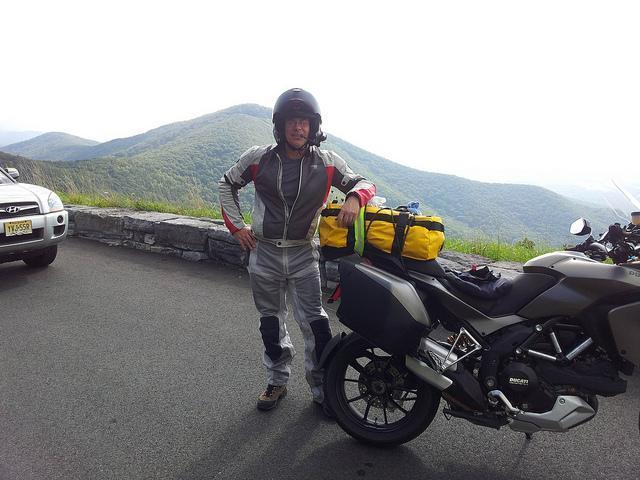How many backpacks are there?
Give a very brief answer. 1. 